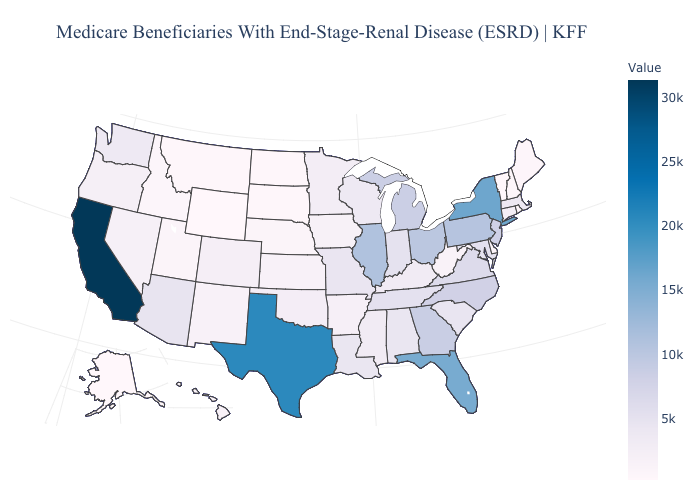Among the states that border Utah , does Colorado have the highest value?
Concise answer only. No. Does the map have missing data?
Concise answer only. No. Among the states that border Idaho , does Wyoming have the lowest value?
Be succinct. Yes. Among the states that border Rhode Island , does Massachusetts have the lowest value?
Quick response, please. No. 